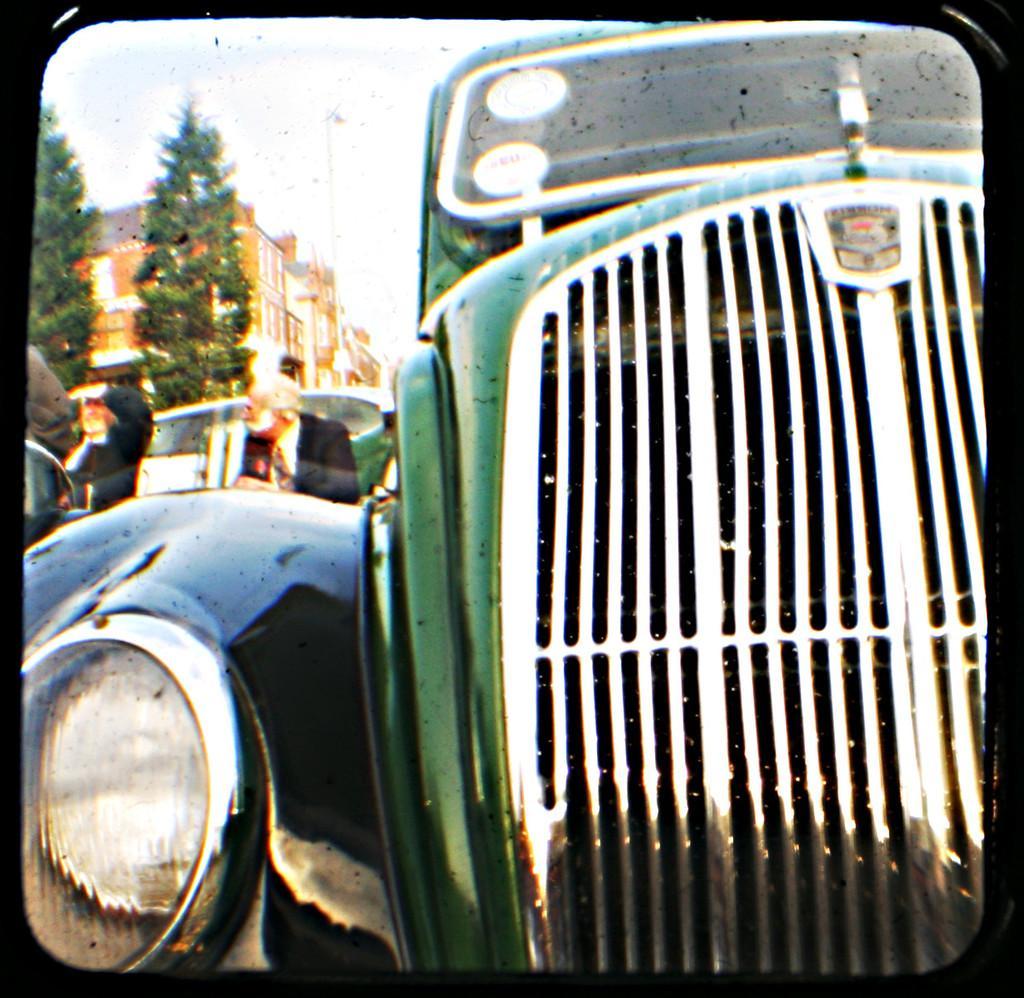Please provide a concise description of this image. In this images we can see a vehicle. In the background there are few persons, vehicle, trees, building and sky. This image is edited with a frame filter. 